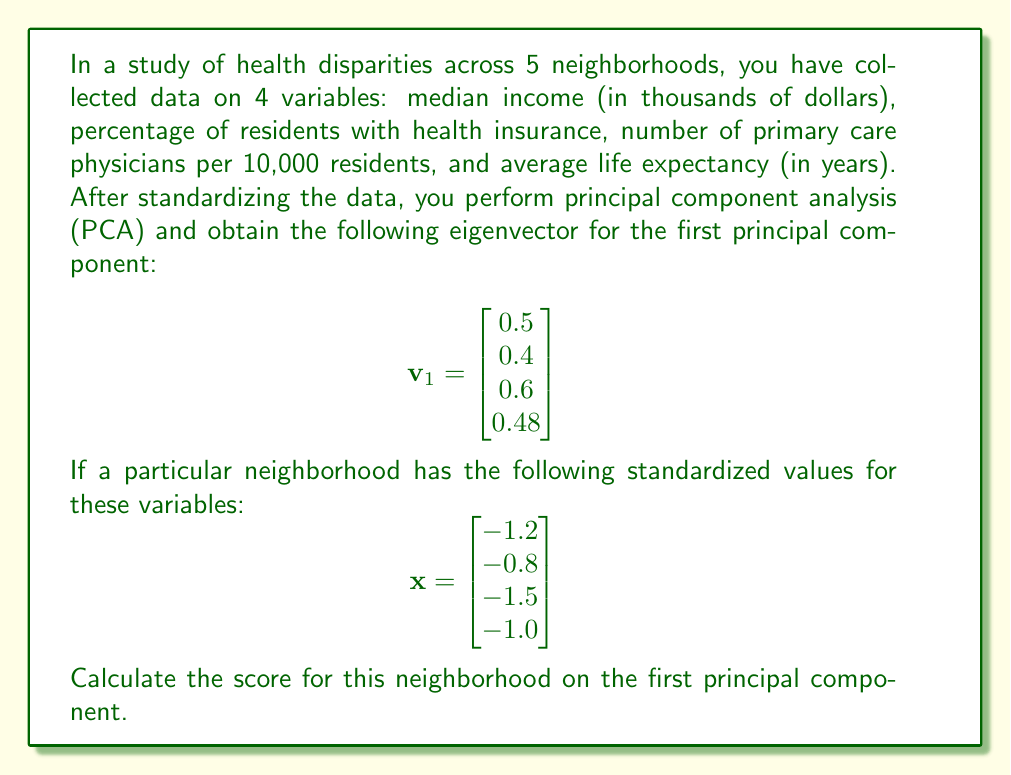Could you help me with this problem? To solve this problem, we need to follow these steps:

1) The score of an observation on a principal component is calculated by taking the dot product of the standardized data vector and the eigenvector for that component.

2) The dot product of two vectors $\mathbf{a} = [a_1, a_2, ..., a_n]$ and $\mathbf{b} = [b_1, b_2, ..., b_n]$ is defined as:

   $$\mathbf{a} \cdot \mathbf{b} = \sum_{i=1}^n a_i b_i = a_1b_1 + a_2b_2 + ... + a_nb_n$$

3) In this case, we need to calculate $\mathbf{x} \cdot \mathbf{v}_1$:

   $$\begin{aligned}
   \mathbf{x} \cdot \mathbf{v}_1 &= (-1.2)(0.5) + (-0.8)(0.4) + (-1.5)(0.6) + (-1.0)(0.48) \\
   &= -0.6 - 0.32 - 0.9 - 0.48
   \end{aligned}$$

4) Summing these values:

   $$\mathbf{x} \cdot \mathbf{v}_1 = -2.3$$

This value (-2.3) is the score for this neighborhood on the first principal component.
Answer: -2.3 